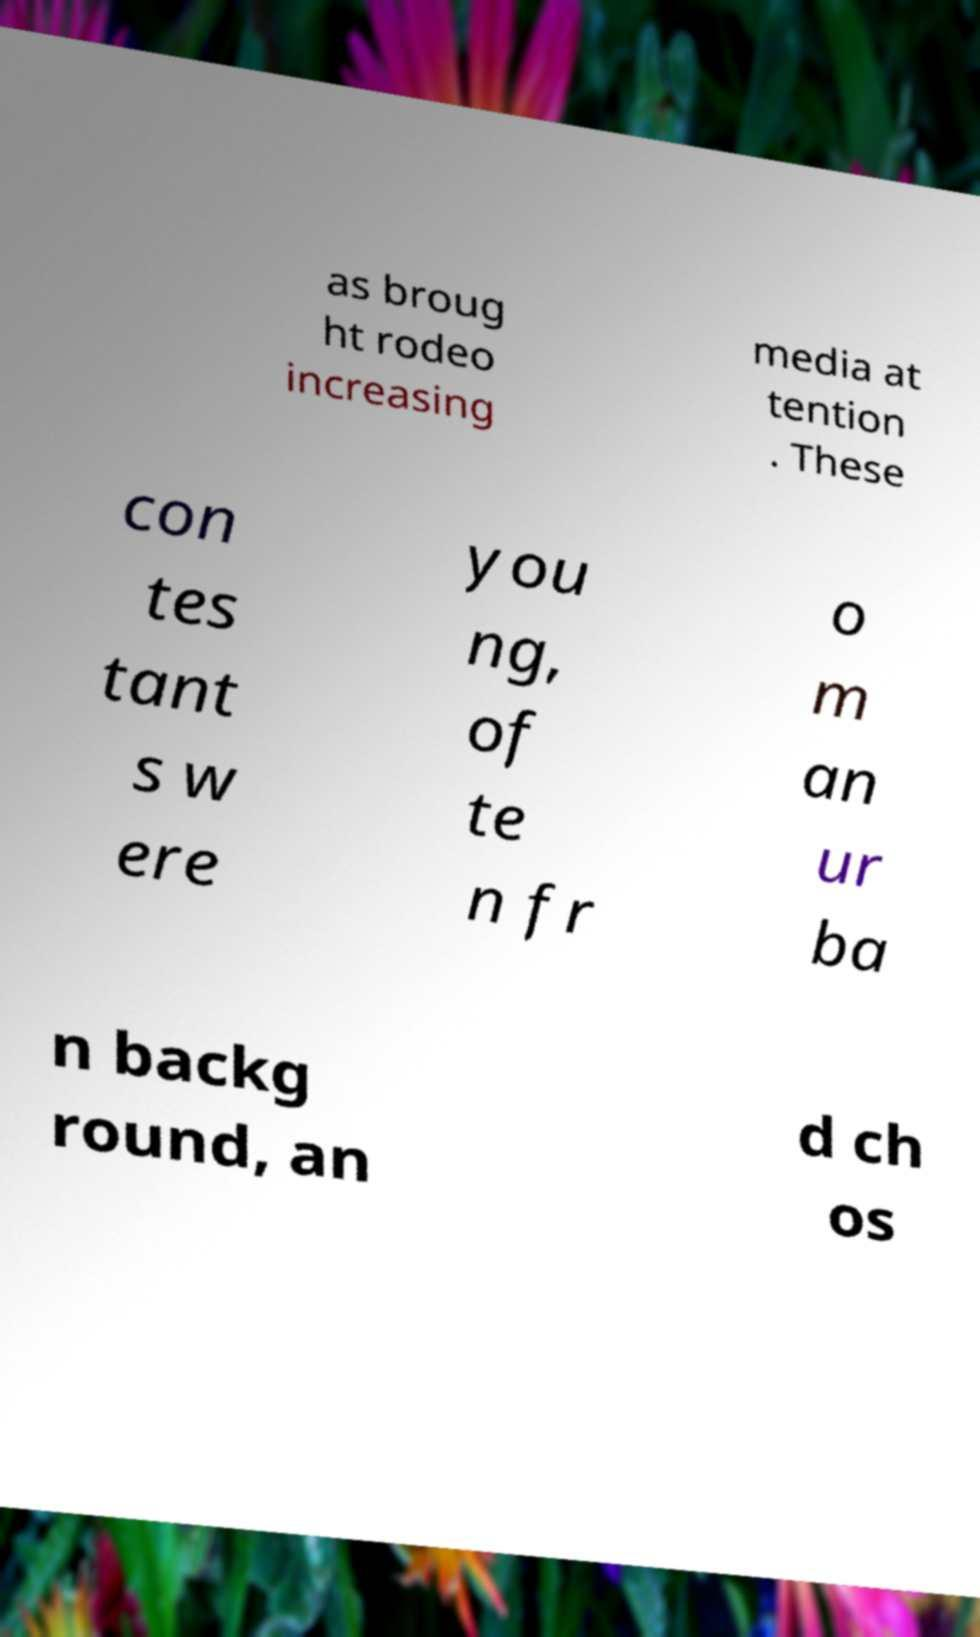Please read and relay the text visible in this image. What does it say? as broug ht rodeo increasing media at tention . These con tes tant s w ere you ng, of te n fr o m an ur ba n backg round, an d ch os 